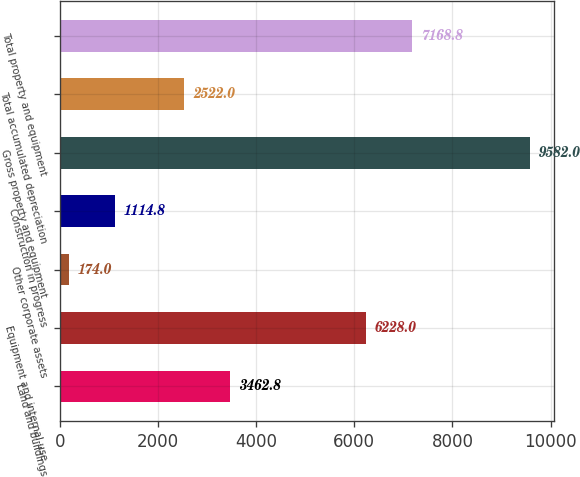Convert chart to OTSL. <chart><loc_0><loc_0><loc_500><loc_500><bar_chart><fcel>Land and buildings<fcel>Equipment and internal-use<fcel>Other corporate assets<fcel>Construction in progress<fcel>Gross property and equipment<fcel>Total accumulated depreciation<fcel>Total property and equipment<nl><fcel>3462.8<fcel>6228<fcel>174<fcel>1114.8<fcel>9582<fcel>2522<fcel>7168.8<nl></chart> 